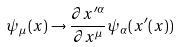<formula> <loc_0><loc_0><loc_500><loc_500>\psi _ { \mu } ( x ) \to \frac { \partial x ^ { \prime \alpha } } { \partial x ^ { \mu } } \psi _ { \alpha } ( x ^ { \prime } ( x ) )</formula> 